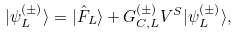<formula> <loc_0><loc_0><loc_500><loc_500>| \psi _ { L } ^ { ( \pm ) } \rangle = | \hat { F } _ { L } \rangle + G _ { C , L } ^ { ( \pm ) } V ^ { S } | \psi _ { L } ^ { ( \pm ) } \rangle ,</formula> 